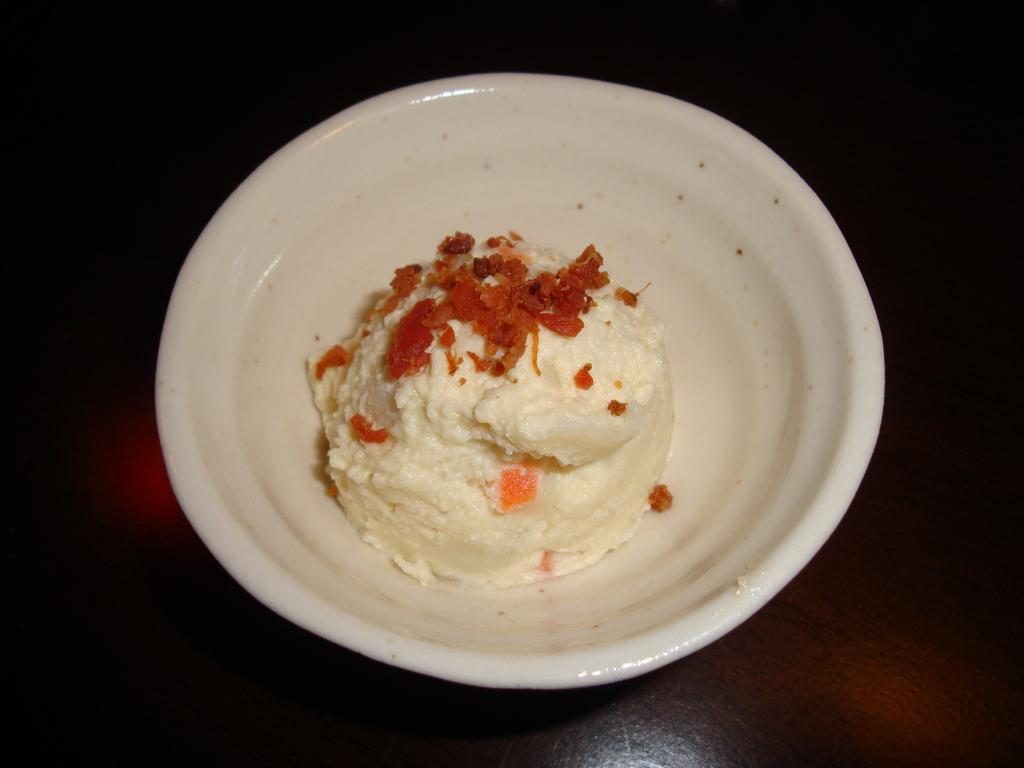What is the main subject of the image? The main subject of the image is an ice cream. Where is the ice cream located in the image? The ice cream is in a bowl. On what surface is the bowl placed? The bowl is placed on a table. What type of dinosaur can be seen playing with the ice cream in the image? There are no dinosaurs present in the image, and therefore no such activity can be observed. 